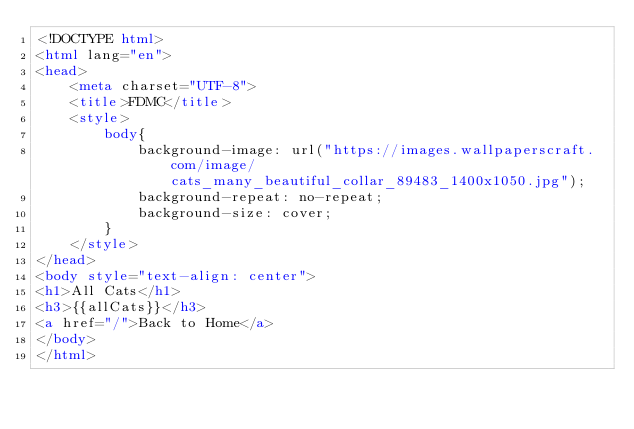Convert code to text. <code><loc_0><loc_0><loc_500><loc_500><_HTML_><!DOCTYPE html>
<html lang="en">
<head>
    <meta charset="UTF-8">
    <title>FDMC</title>
    <style>
        body{
            background-image: url("https://images.wallpaperscraft.com/image/cats_many_beautiful_collar_89483_1400x1050.jpg");
            background-repeat: no-repeat;
            background-size: cover;
        }
    </style>
</head>
<body style="text-align: center">
<h1>All Cats</h1>
<h3>{{allCats}}</h3>
<a href="/">Back to Home</a>
</body>
</html></code> 